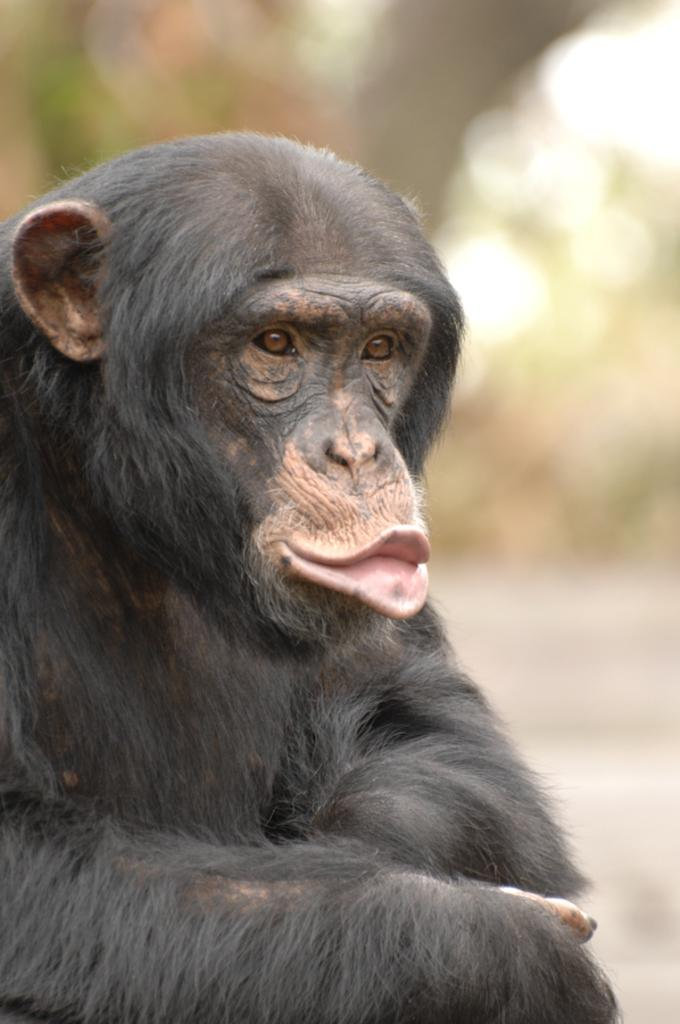What type of animal is in the image? There is a monkey in the image. What color is the monkey? The monkey is black in color. Where can the monkey be found shopping in the image? There is no indication in the image that the monkey is shopping or in a shop; it is simply a black monkey. 